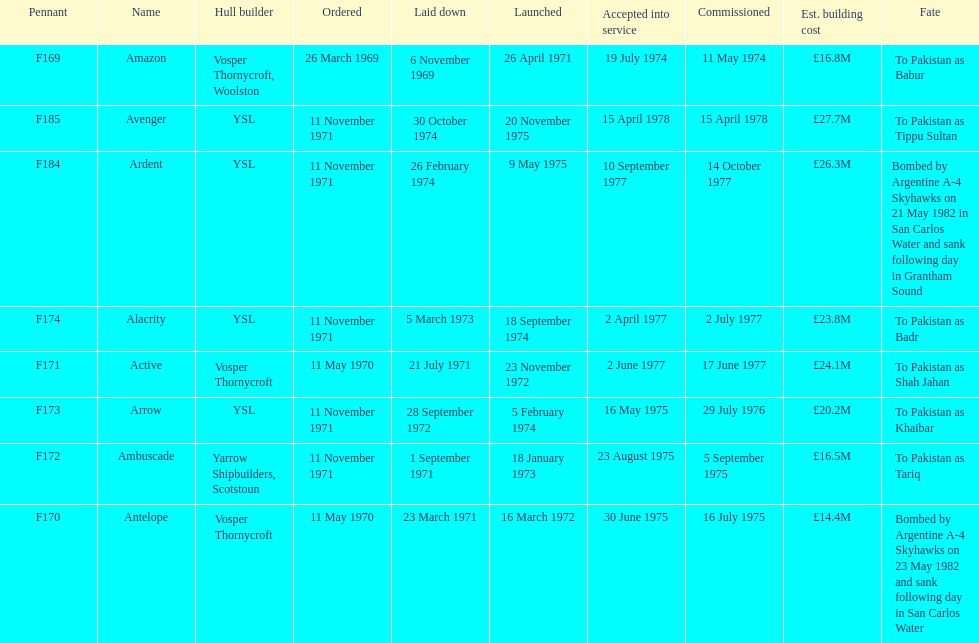What is the last name listed on this chart? Avenger. 